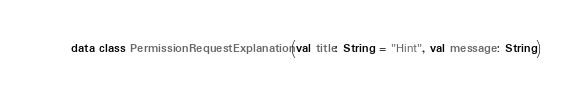<code> <loc_0><loc_0><loc_500><loc_500><_Kotlin_>
data class PermissionRequestExplanation(val title: String = "Hint", val message: String)</code> 